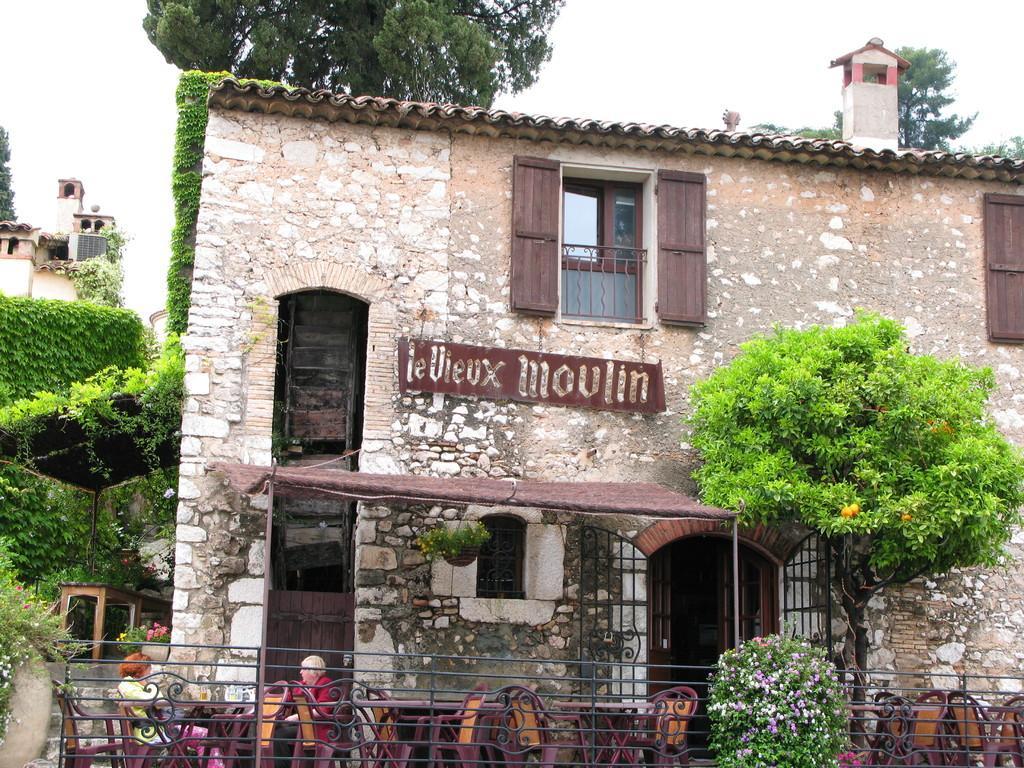Can you describe this image briefly? There is a building with brick wall, windows, doors and something is written on the building. In front of the building there is a tree, tables, chairs, railings. Also there is a plant with flowers. Some people are sitting on chairs. In the background there are trees and sky. 